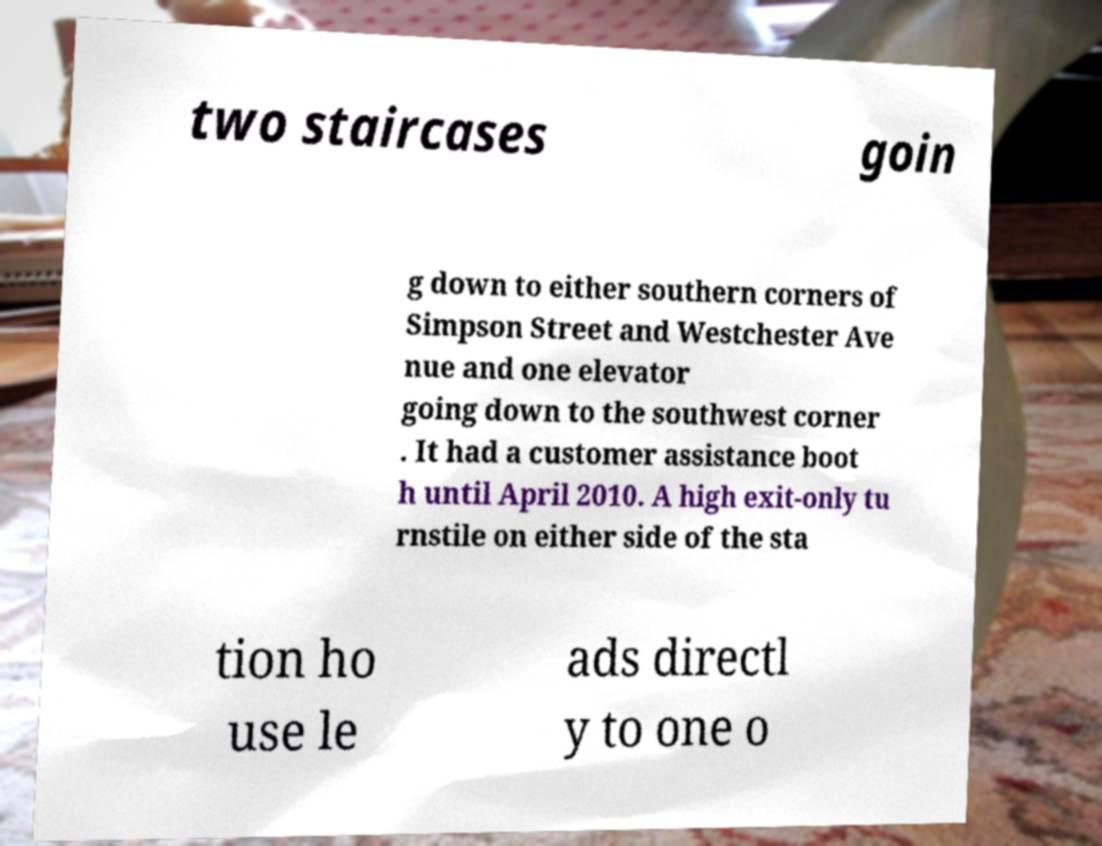I need the written content from this picture converted into text. Can you do that? two staircases goin g down to either southern corners of Simpson Street and Westchester Ave nue and one elevator going down to the southwest corner . It had a customer assistance boot h until April 2010. A high exit-only tu rnstile on either side of the sta tion ho use le ads directl y to one o 